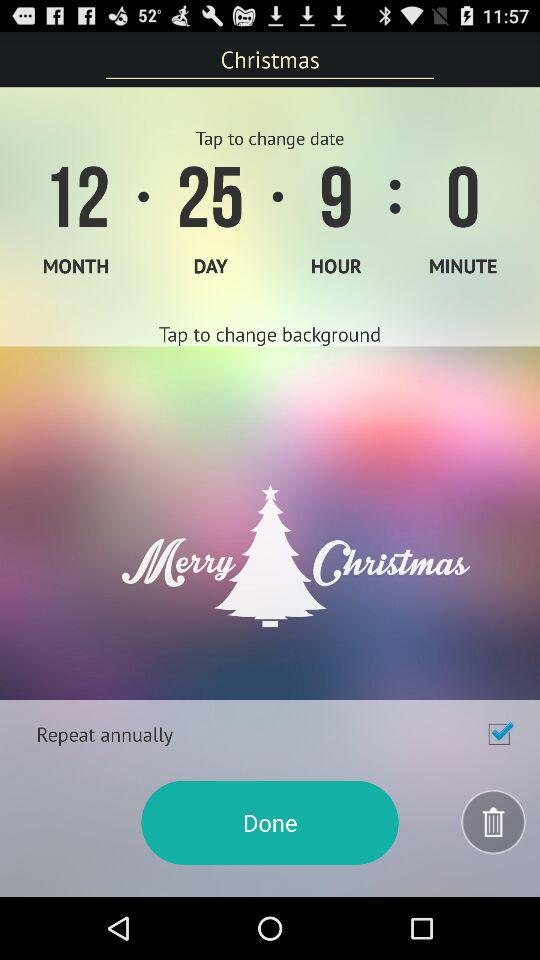Is "Repeat annually" checked or unchecked? "Repeat annually" is checked. 